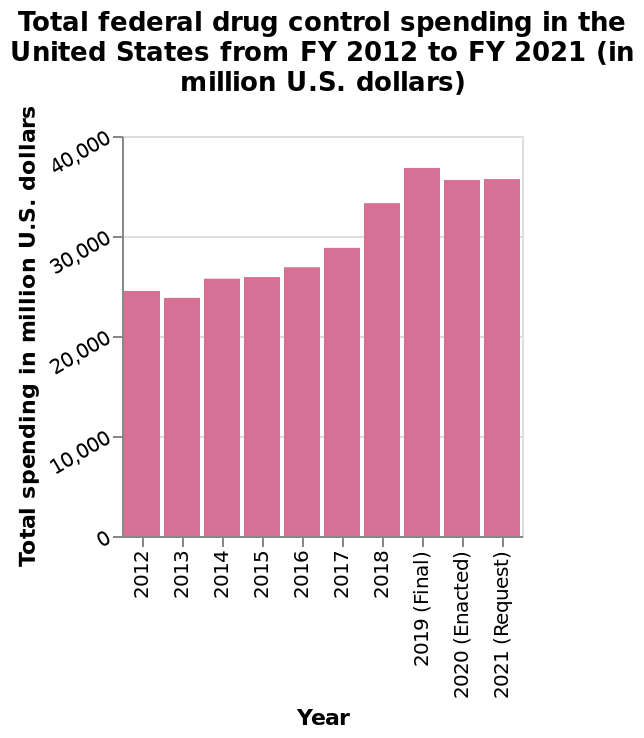<image>
What is the range of the y-axis in the bar diagram?  The range of the y-axis in the bar diagram is from 0 to 40,000 million U.S. dollars. Has the spend on drug control been consistent before 2017? Yes, the spend on drug control was consistently below 30,000 million US dollars before 2017. What is the title of the bar diagram?  The title of the bar diagram is "Total federal drug control spending in the United States from FY 2012 to FY 2021 (in million U.S. dollars)." 